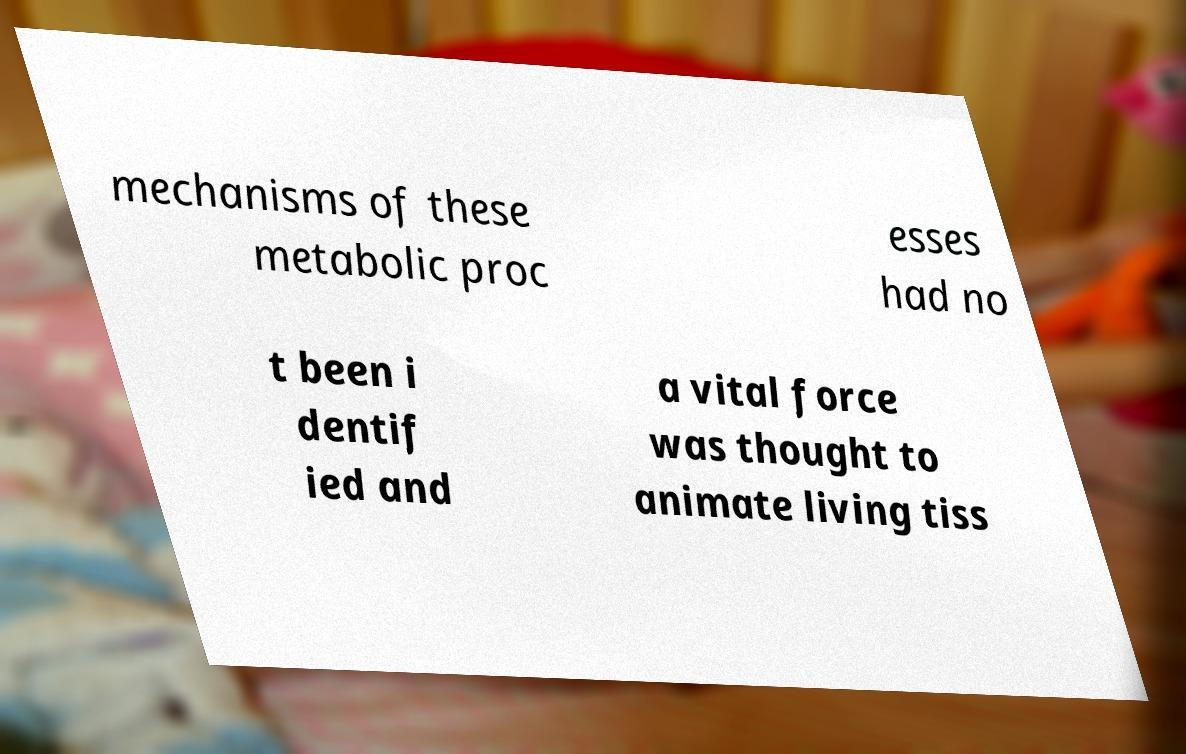Can you accurately transcribe the text from the provided image for me? mechanisms of these metabolic proc esses had no t been i dentif ied and a vital force was thought to animate living tiss 